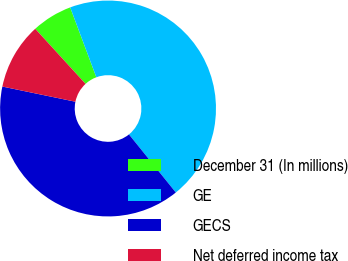Convert chart. <chart><loc_0><loc_0><loc_500><loc_500><pie_chart><fcel>December 31 (In millions)<fcel>GE<fcel>GECS<fcel>Net deferred income tax<nl><fcel>6.08%<fcel>44.9%<fcel>39.06%<fcel>9.96%<nl></chart> 